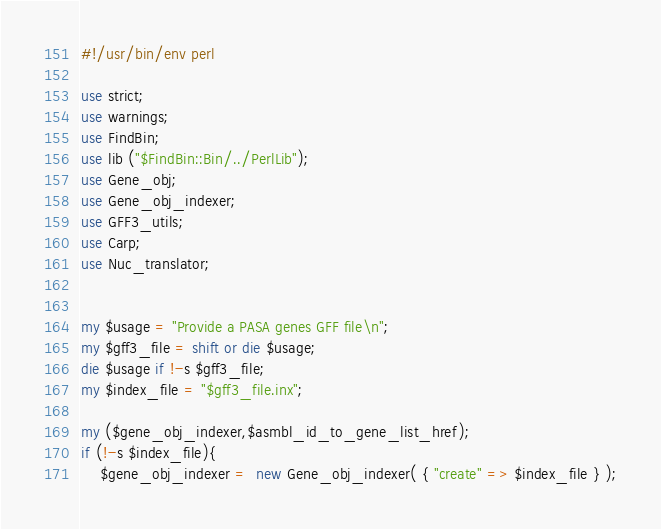<code> <loc_0><loc_0><loc_500><loc_500><_Perl_>#!/usr/bin/env perl

use strict;
use warnings;
use FindBin;
use lib ("$FindBin::Bin/../PerlLib");
use Gene_obj;
use Gene_obj_indexer;
use GFF3_utils;
use Carp;
use Nuc_translator;


my $usage = "Provide a PASA genes GFF file\n";
my $gff3_file = shift or die $usage;
die $usage if !-s $gff3_file;
my $index_file = "$gff3_file.inx";

my ($gene_obj_indexer,$asmbl_id_to_gene_list_href);
if (!-s $index_file){
	$gene_obj_indexer =  new Gene_obj_indexer( { "create" => $index_file } );</code> 